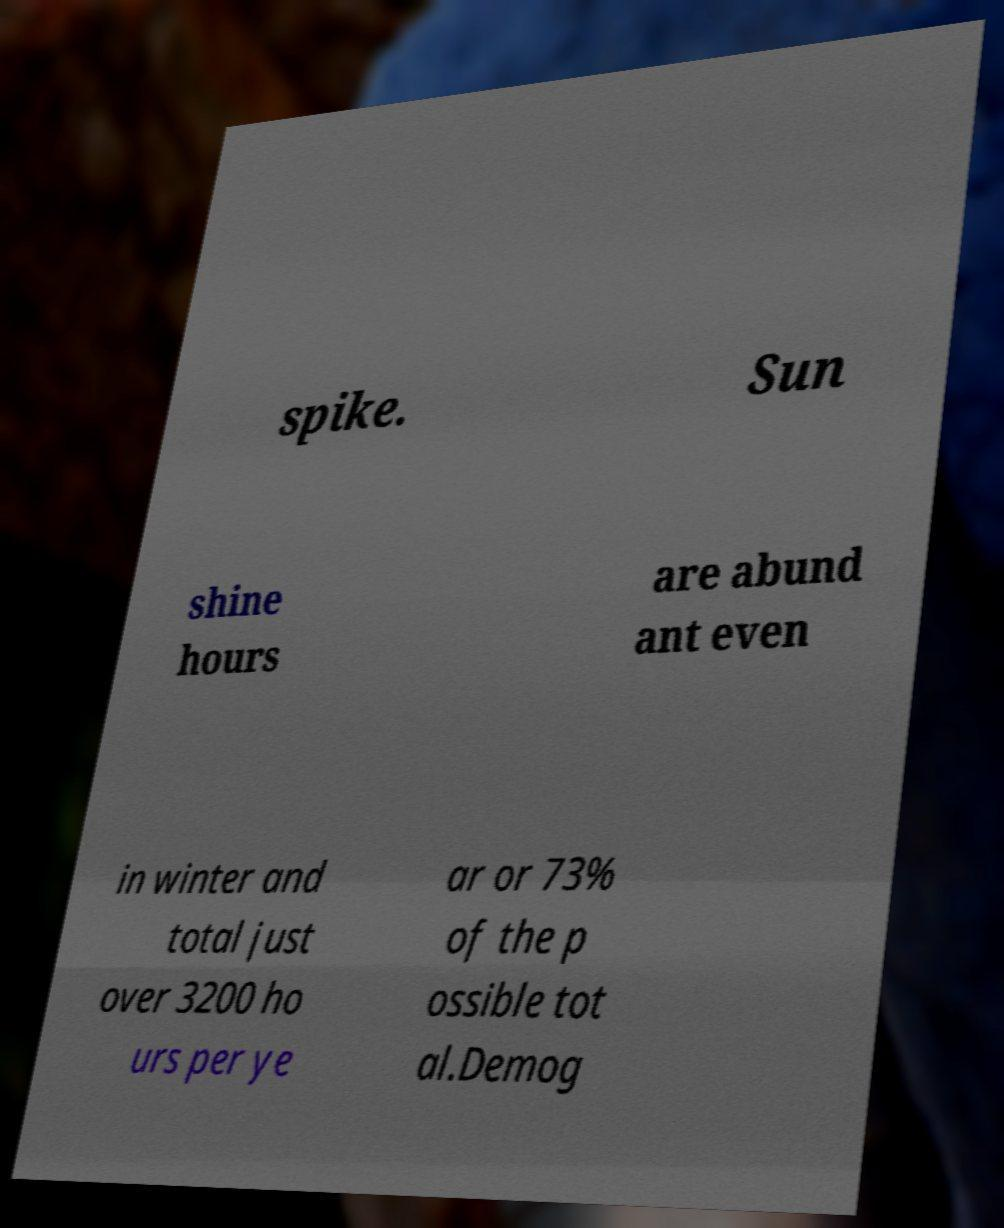What messages or text are displayed in this image? I need them in a readable, typed format. spike. Sun shine hours are abund ant even in winter and total just over 3200 ho urs per ye ar or 73% of the p ossible tot al.Demog 